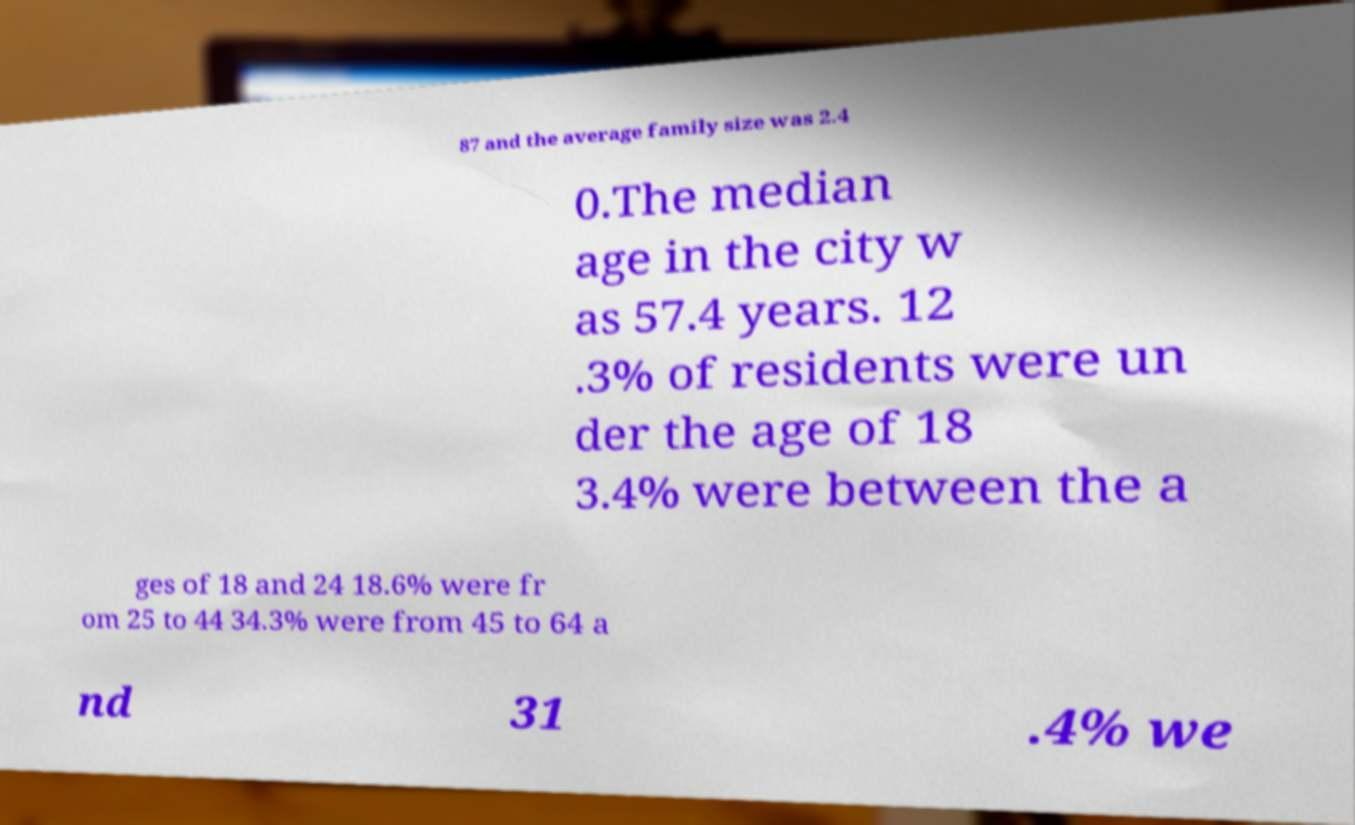Please identify and transcribe the text found in this image. 87 and the average family size was 2.4 0.The median age in the city w as 57.4 years. 12 .3% of residents were un der the age of 18 3.4% were between the a ges of 18 and 24 18.6% were fr om 25 to 44 34.3% were from 45 to 64 a nd 31 .4% we 